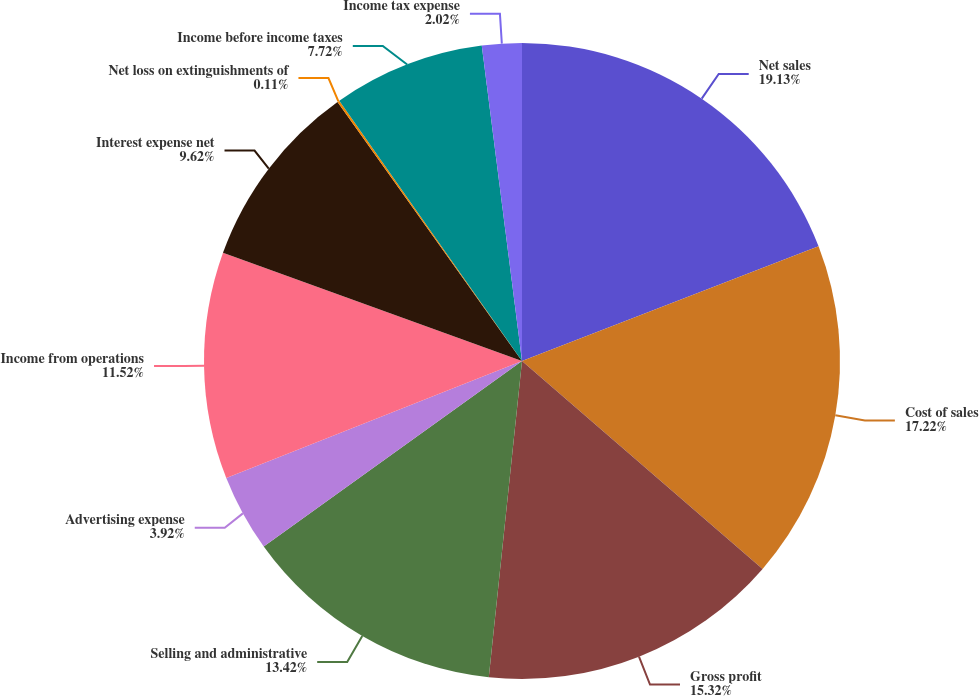Convert chart to OTSL. <chart><loc_0><loc_0><loc_500><loc_500><pie_chart><fcel>Net sales<fcel>Cost of sales<fcel>Gross profit<fcel>Selling and administrative<fcel>Advertising expense<fcel>Income from operations<fcel>Interest expense net<fcel>Net loss on extinguishments of<fcel>Income before income taxes<fcel>Income tax expense<nl><fcel>19.12%<fcel>17.22%<fcel>15.32%<fcel>13.42%<fcel>3.92%<fcel>11.52%<fcel>9.62%<fcel>0.11%<fcel>7.72%<fcel>2.02%<nl></chart> 